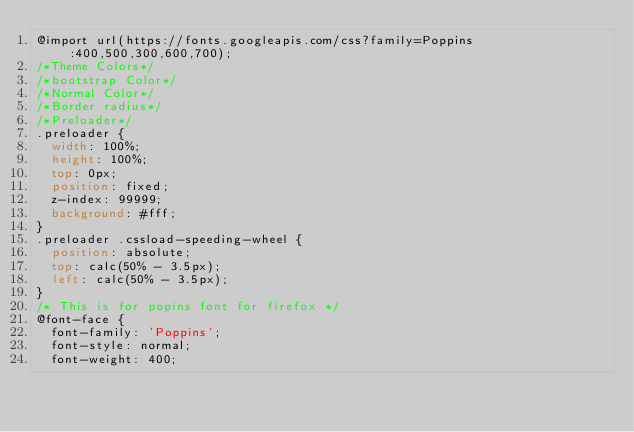Convert code to text. <code><loc_0><loc_0><loc_500><loc_500><_CSS_>@import url(https://fonts.googleapis.com/css?family=Poppins:400,500,300,600,700);
/*Theme Colors*/
/*bootstrap Color*/
/*Normal Color*/
/*Border radius*/
/*Preloader*/
.preloader {
  width: 100%;
  height: 100%;
  top: 0px;
  position: fixed;
  z-index: 99999;
  background: #fff;
}
.preloader .cssload-speeding-wheel {
  position: absolute;
  top: calc(50% - 3.5px);
  left: calc(50% - 3.5px);
}
/* This is for popins font for firefox */
@font-face {
  font-family: 'Poppins';
  font-style: normal;
  font-weight: 400;</code> 